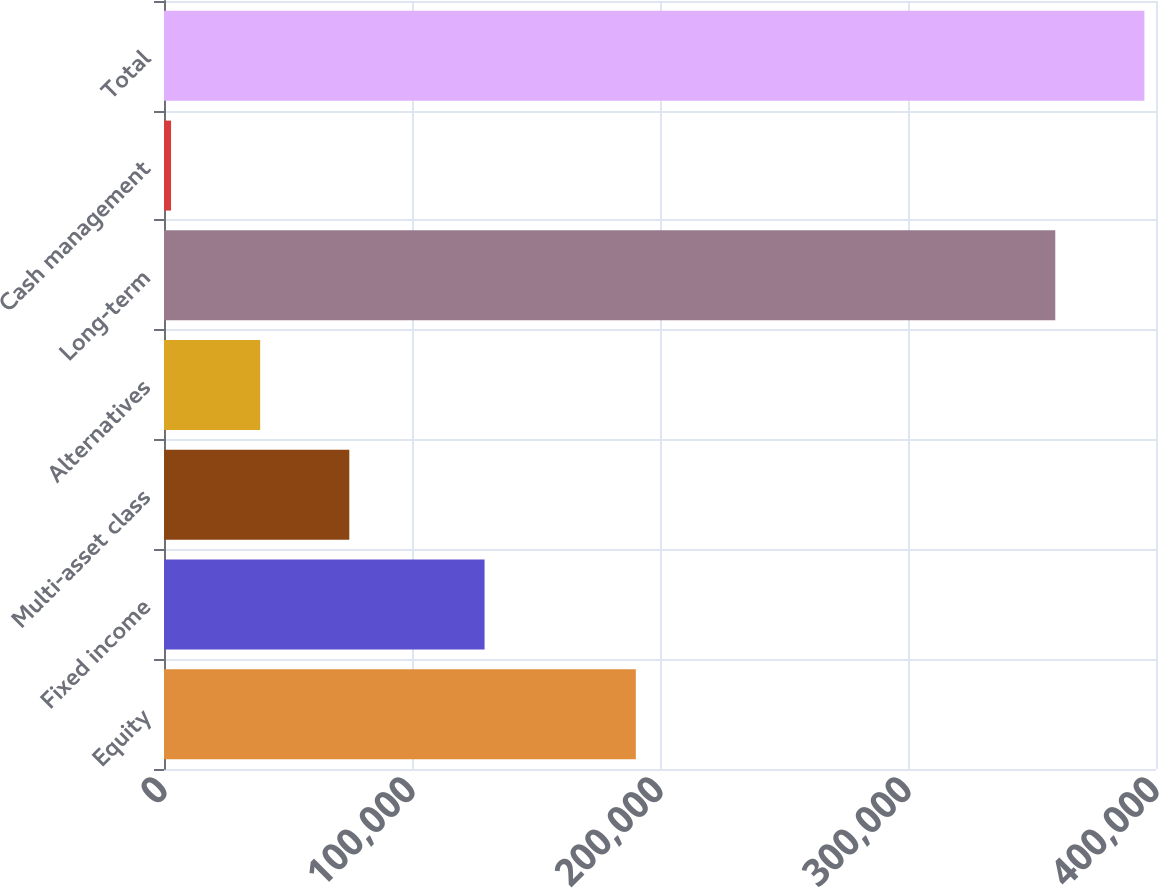<chart> <loc_0><loc_0><loc_500><loc_500><bar_chart><fcel>Equity<fcel>Fixed income<fcel>Multi-asset class<fcel>Alternatives<fcel>Long-term<fcel>Cash management<fcel>Total<nl><fcel>190252<fcel>129258<fcel>74719.6<fcel>38781.3<fcel>359383<fcel>2843<fcel>395321<nl></chart> 